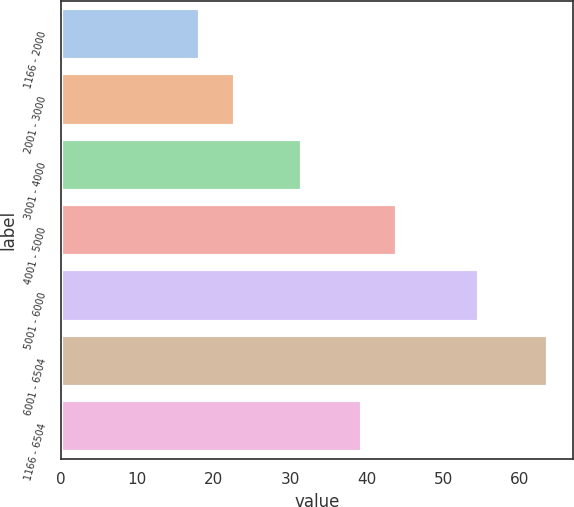Convert chart to OTSL. <chart><loc_0><loc_0><loc_500><loc_500><bar_chart><fcel>1166 - 2000<fcel>2001 - 3000<fcel>3001 - 4000<fcel>4001 - 5000<fcel>5001 - 6000<fcel>6001 - 6504<fcel>1166 - 6504<nl><fcel>18.23<fcel>22.78<fcel>31.56<fcel>43.94<fcel>54.67<fcel>63.72<fcel>39.39<nl></chart> 